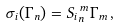Convert formula to latex. <formula><loc_0><loc_0><loc_500><loc_500>\sigma _ { i } ( \Gamma _ { n } ) = { S _ { i } } _ { n } ^ { \, m } \Gamma _ { m } \, ,</formula> 